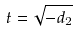Convert formula to latex. <formula><loc_0><loc_0><loc_500><loc_500>t = \sqrt { - d _ { 2 } }</formula> 